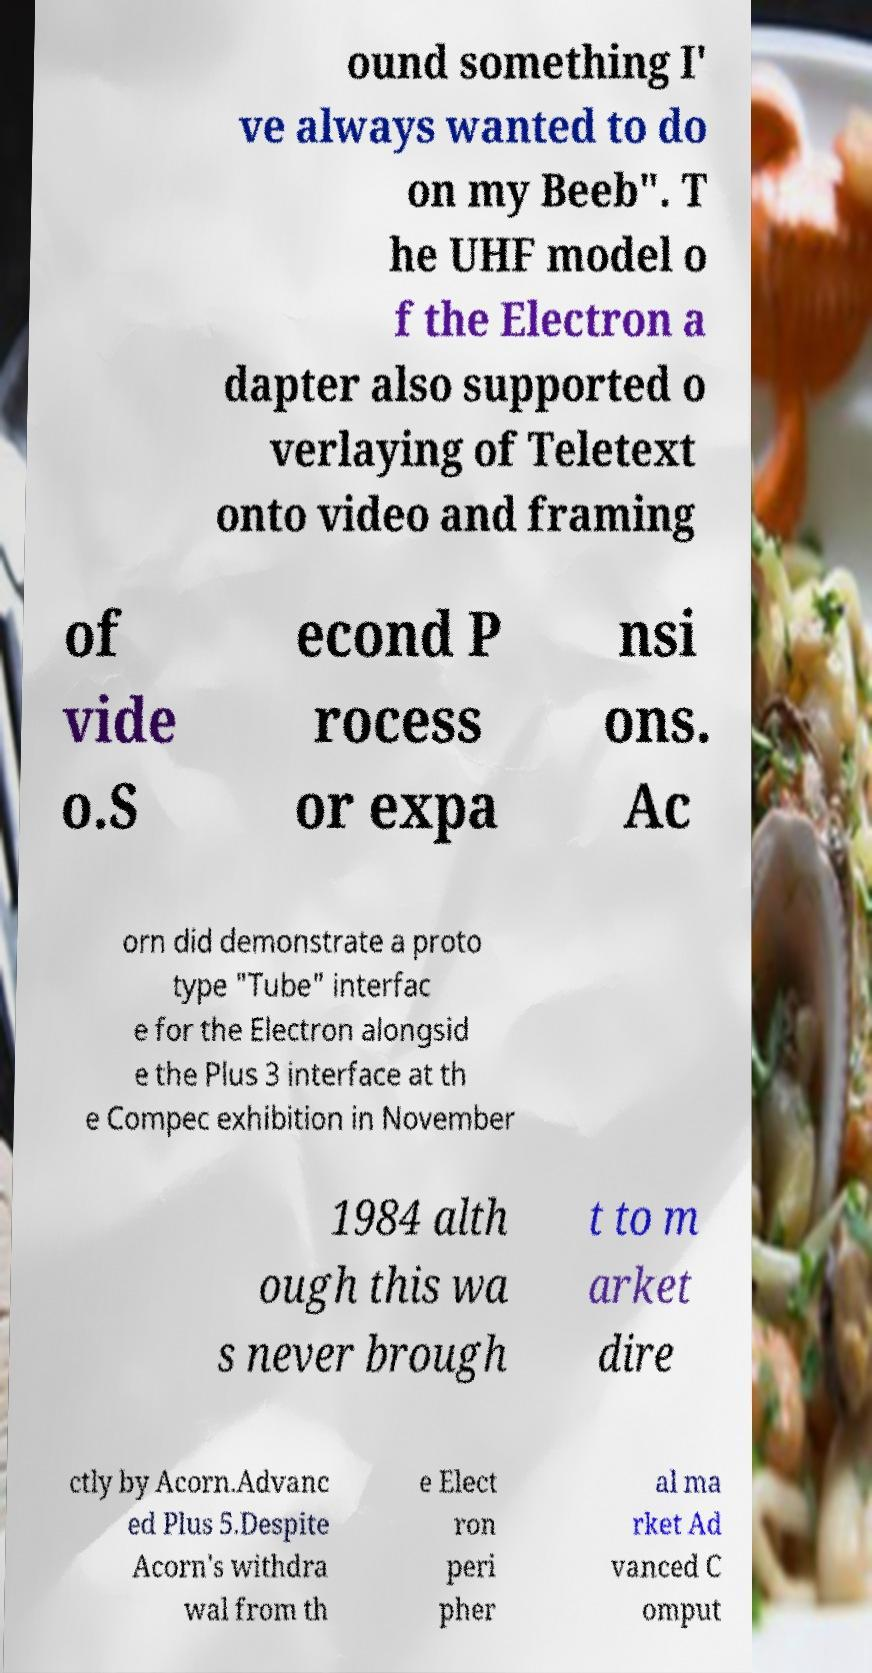There's text embedded in this image that I need extracted. Can you transcribe it verbatim? ound something I' ve always wanted to do on my Beeb". T he UHF model o f the Electron a dapter also supported o verlaying of Teletext onto video and framing of vide o.S econd P rocess or expa nsi ons. Ac orn did demonstrate a proto type "Tube" interfac e for the Electron alongsid e the Plus 3 interface at th e Compec exhibition in November 1984 alth ough this wa s never brough t to m arket dire ctly by Acorn.Advanc ed Plus 5.Despite Acorn's withdra wal from th e Elect ron peri pher al ma rket Ad vanced C omput 